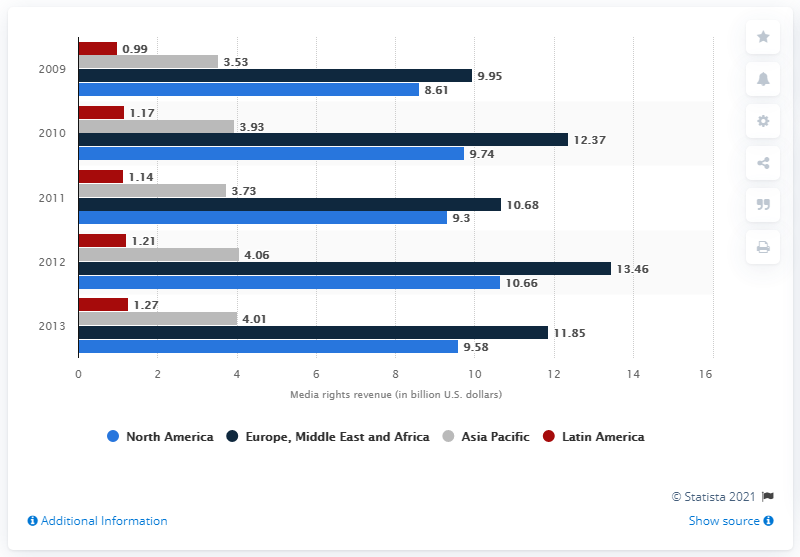Draw attention to some important aspects in this diagram. The projected total revenue from media rights in the Asia Pacific region in 2011 was estimated to be 3.73 billion dollars. In 2009, the total revenue generated worldwide from sports broadcast media rights was generated by region. 